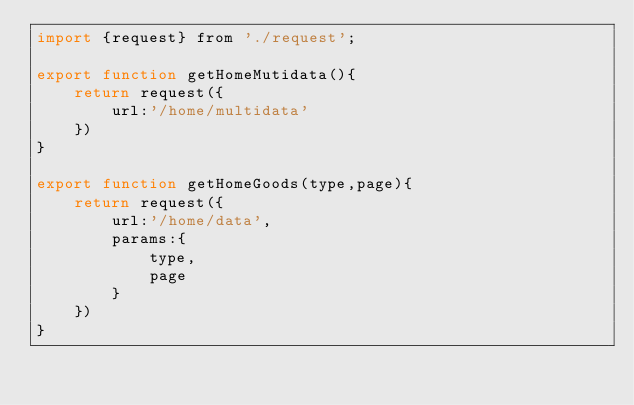Convert code to text. <code><loc_0><loc_0><loc_500><loc_500><_JavaScript_>import {request} from './request';

export function getHomeMutidata(){
    return request({
        url:'/home/multidata'
    })
}

export function getHomeGoods(type,page){
    return request({
        url:'/home/data',
        params:{
            type,
            page
        }
    })
}</code> 